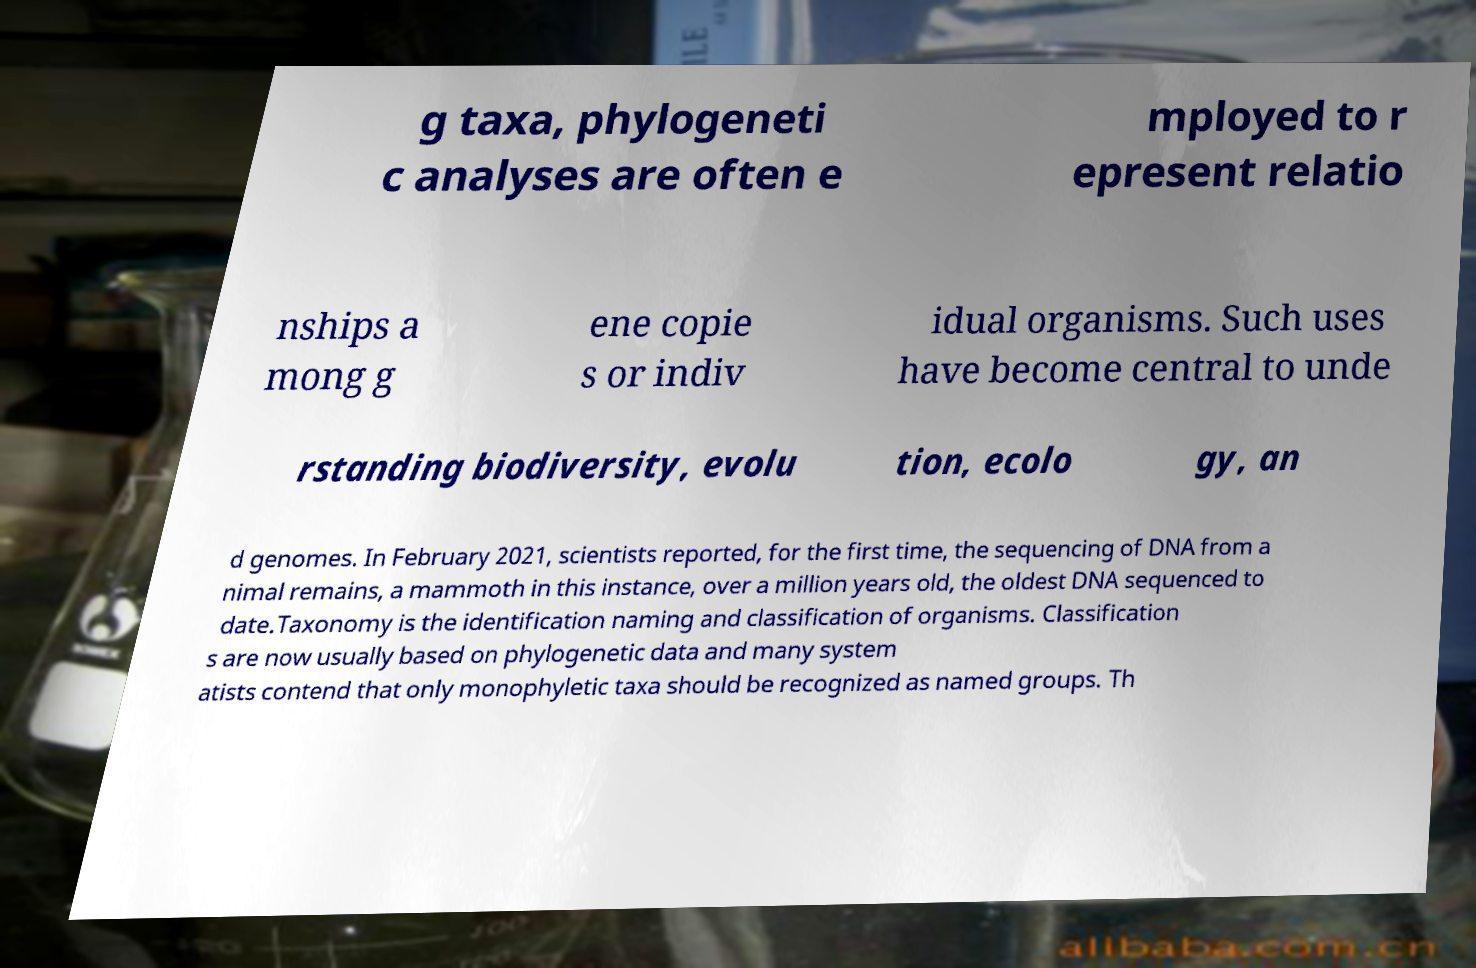Can you read and provide the text displayed in the image?This photo seems to have some interesting text. Can you extract and type it out for me? g taxa, phylogeneti c analyses are often e mployed to r epresent relatio nships a mong g ene copie s or indiv idual organisms. Such uses have become central to unde rstanding biodiversity, evolu tion, ecolo gy, an d genomes. In February 2021, scientists reported, for the first time, the sequencing of DNA from a nimal remains, a mammoth in this instance, over a million years old, the oldest DNA sequenced to date.Taxonomy is the identification naming and classification of organisms. Classification s are now usually based on phylogenetic data and many system atists contend that only monophyletic taxa should be recognized as named groups. Th 